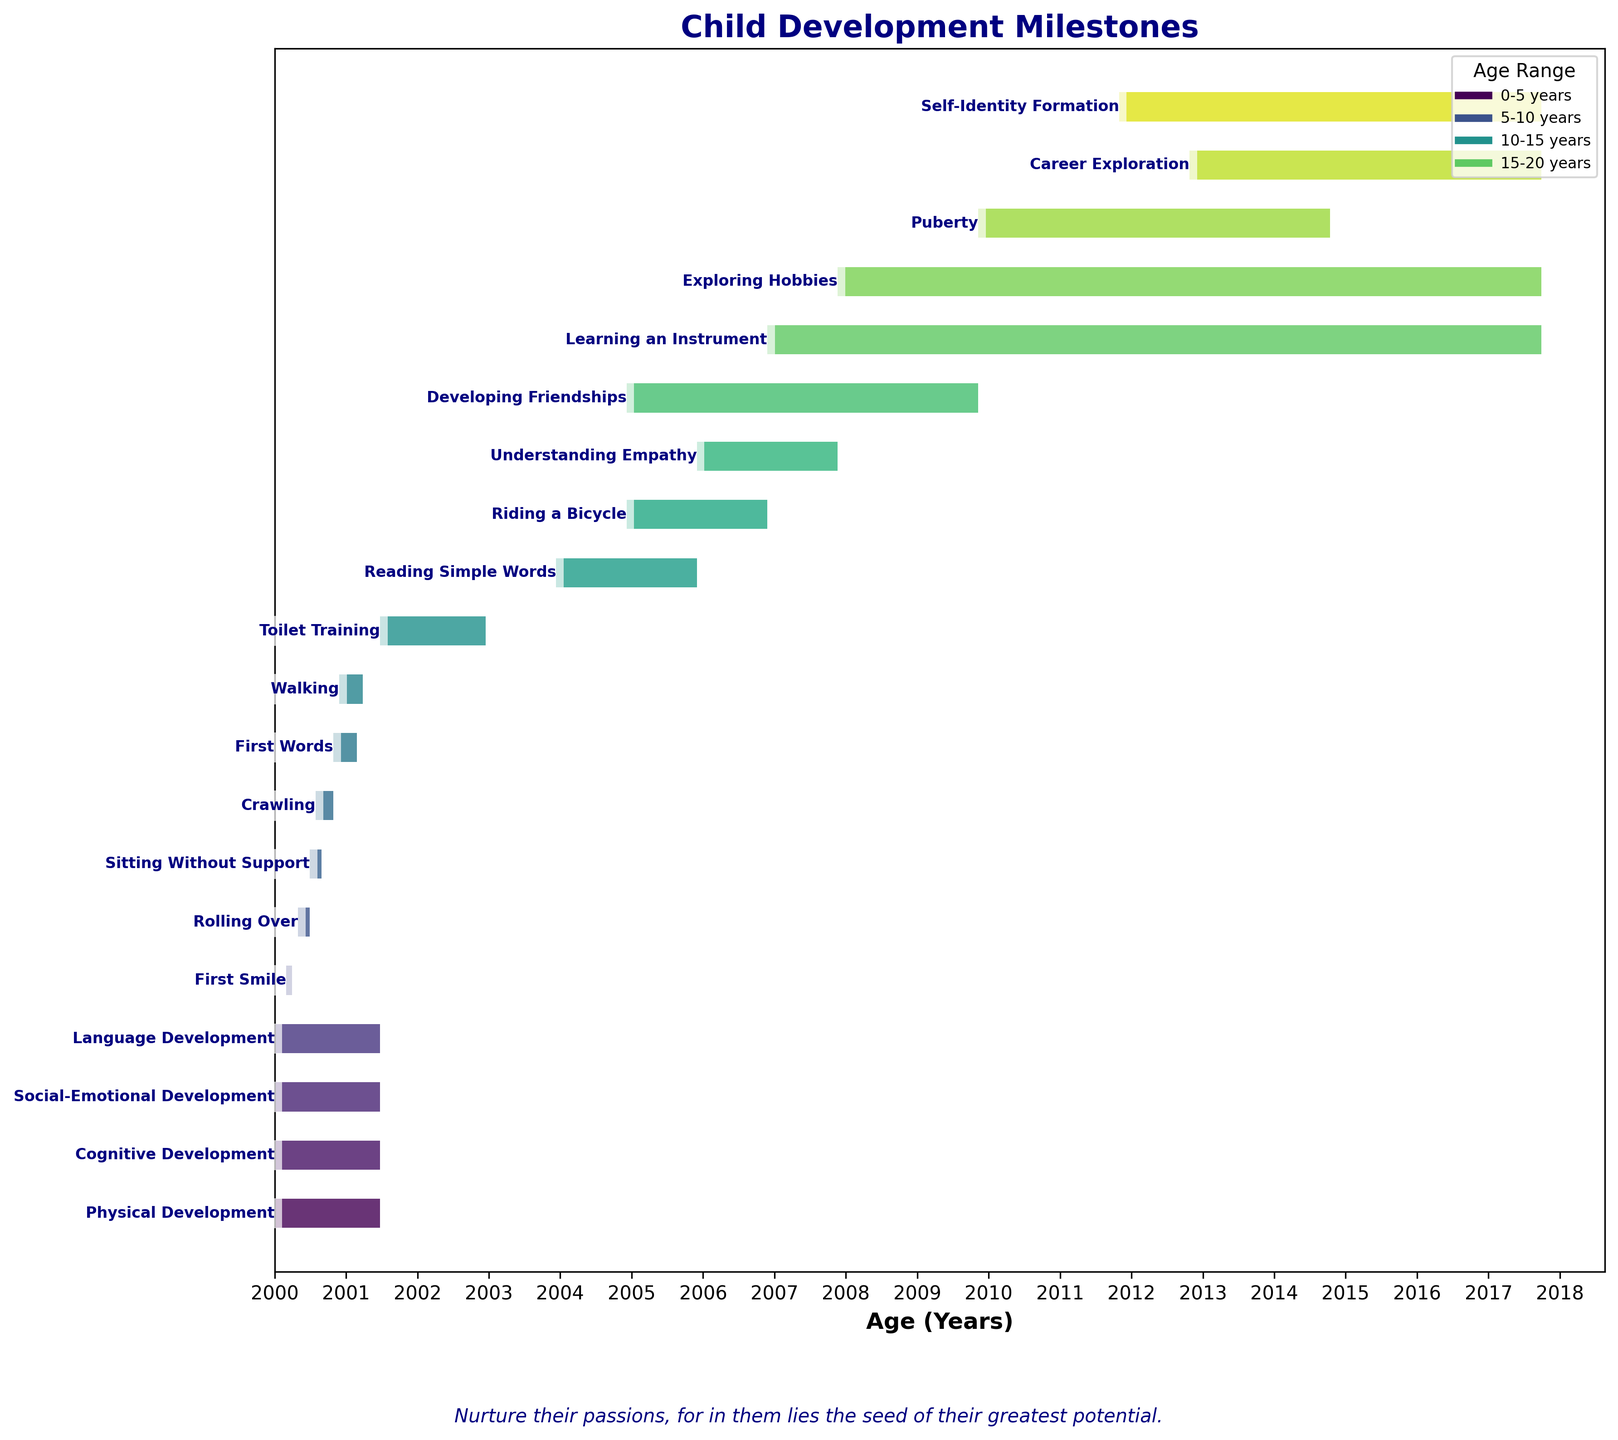what is the milestone that takes place between ages 4 and 6? The Gantt Chart shows milestones along a timeline. Look for the milestone placed between the ages corresponding to 4 and 6 years on the x-axis. The bar labeled "Rolling Over" matches this age range.
Answer: Rolling Over when does Reading Simple Words begin and end? Find the bar labeled "Reading Simple Words" on the Gantt Chart. The x-axis shows that this milestone starts at age 4 (48 months) and ends at age 6 (72 months).
Answer: Begins at 4 years (48 months) and ends at 6 years (72 months) which development milestone has the longest duration? Evaluate the duration of all milestones by comparing the lengths of the bars visually. "Physical Development," "Cognitive Development," "Social-Emotional Development," and "Language Development" all span from birth to 18 years, which is the longest duration.
Answer: Physical Development, Cognitive Development, Social-Emotional Development, and Language Development is Learning an Instrument longer or shorter than Exploring Hobbies? Identify the bars for "Learning an Instrument" and "Exploring Hobbies" and compare their lengths. "Learning an Instrument" spans from 7 years to 18 years while "Exploring Hobbies" spans from 8 years to 18 years. The former is slightly shorter in duration.
Answer: Shorter how many milestones start before age 1? Count the number of milestones whose bars start within the first year on the x-axis. The milestones are "First Smile," "Rolling Over," "Sitting Without Support," "Crawling," "Physical Development," "Cognitive Development," "Social-Emotional Development," and "Language Development."
Answer: 8 which milestone is associated with understanding empathy? Locate the bar labeled with "Understanding Empathy" on the chart. It spans from ages 6 to 8 years.
Answer: Understanding Empathy when does the milestone for developing friendships begin? Find the bar labeled "Developing Friendships" and check the starting age on the x-axis. It begins at age 5.
Answer: Begins at 5 years what milestone is achieved between 10-14 months? Identify the bar corresponding to the time period of 10 to 14 months. The bar labeled "First Words" falls within this range.
Answer: First Words how many bars correspond to milestones that extend past age 15? Count the number of bars whose rightmost end extends beyond the age of 15 on the x-axis. These milestones are "Physical Development," "Cognitive Development," "Social-Emotional Development," "Language Development," "Learning an Instrument," "Exploring Hobbies," "Career Exploration," and "Self-Identity Formation."
Answer: 8 